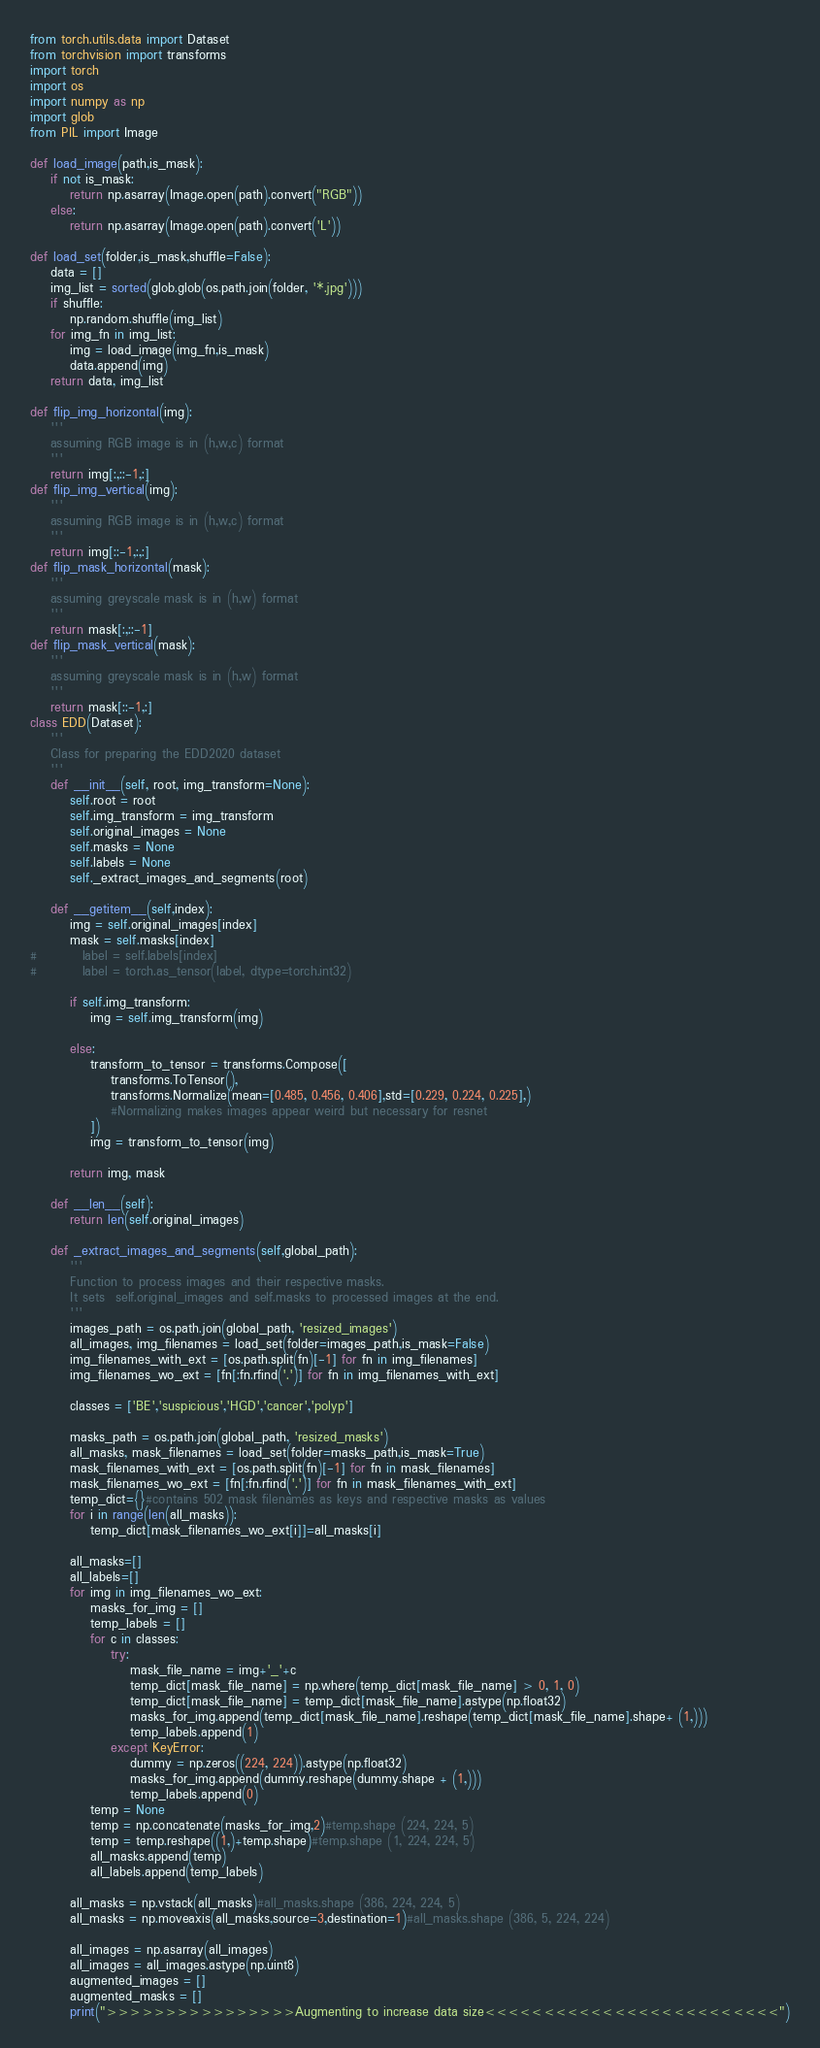Convert code to text. <code><loc_0><loc_0><loc_500><loc_500><_Python_>from torch.utils.data import Dataset
from torchvision import transforms
import torch
import os
import numpy as np
import glob
from PIL import Image

def load_image(path,is_mask):
    if not is_mask:
        return np.asarray(Image.open(path).convert("RGB"))
    else:
        return np.asarray(Image.open(path).convert('L'))

def load_set(folder,is_mask,shuffle=False):
    data = []
    img_list = sorted(glob.glob(os.path.join(folder, '*.jpg')))
    if shuffle:
        np.random.shuffle(img_list)
    for img_fn in img_list:
        img = load_image(img_fn,is_mask)
        data.append(img)
    return data, img_list

def flip_img_horizontal(img):
    '''
    assuming RGB image is in (h,w,c) format
    '''
    return img[:,::-1,:]
def flip_img_vertical(img):
    '''
    assuming RGB image is in (h,w,c) format
    '''
    return img[::-1,:,:]
def flip_mask_horizontal(mask):
    '''
    assuming greyscale mask is in (h,w) format
    '''
    return mask[:,::-1]
def flip_mask_vertical(mask):
    '''
    assuming greyscale mask is in (h,w) format
    '''
    return mask[::-1,:]
class EDD(Dataset):
    '''
    Class for preparing the EDD2020 dataset
    '''
    def __init__(self, root, img_transform=None):
        self.root = root
        self.img_transform = img_transform
        self.original_images = None
        self.masks = None
        self.labels = None
        self._extract_images_and_segments(root)

    def __getitem__(self,index):
        img = self.original_images[index]
        mask = self.masks[index]
#         label = self.labels[index]
#         label = torch.as_tensor(label, dtype=torch.int32)
    
        if self.img_transform:
            img = self.img_transform(img)
            
        else:
            transform_to_tensor = transforms.Compose([
                transforms.ToTensor(),
                transforms.Normalize(mean=[0.485, 0.456, 0.406],std=[0.229, 0.224, 0.225],)
                #Normalizing makes images appear weird but necessary for resnet
            ])
            img = transform_to_tensor(img)
        
        return img, mask

    def __len__(self):
        return len(self.original_images)
    
    def _extract_images_and_segments(self,global_path):
        '''
        Function to process images and their respective masks.
        It sets  self.original_images and self.masks to processed images at the end.
        '''
        images_path = os.path.join(global_path, 'resized_images')
        all_images, img_filenames = load_set(folder=images_path,is_mask=False)
        img_filenames_with_ext = [os.path.split(fn)[-1] for fn in img_filenames]
        img_filenames_wo_ext = [fn[:fn.rfind('.')] for fn in img_filenames_with_ext]

        classes = ['BE','suspicious','HGD','cancer','polyp']

        masks_path = os.path.join(global_path, 'resized_masks')
        all_masks, mask_filenames = load_set(folder=masks_path,is_mask=True)
        mask_filenames_with_ext = [os.path.split(fn)[-1] for fn in mask_filenames]
        mask_filenames_wo_ext = [fn[:fn.rfind('.')] for fn in mask_filenames_with_ext]
        temp_dict={}#contains 502 mask filenames as keys and respective masks as values
        for i in range(len(all_masks)):
            temp_dict[mask_filenames_wo_ext[i]]=all_masks[i]

        all_masks=[]
        all_labels=[]
        for img in img_filenames_wo_ext:
            masks_for_img = []
            temp_labels = []
            for c in classes:
                try:
                    mask_file_name = img+'_'+c
                    temp_dict[mask_file_name] = np.where(temp_dict[mask_file_name] > 0, 1, 0)
                    temp_dict[mask_file_name] = temp_dict[mask_file_name].astype(np.float32)
                    masks_for_img.append(temp_dict[mask_file_name].reshape(temp_dict[mask_file_name].shape+ (1,)))
                    temp_labels.append(1)
                except KeyError:
                    dummy = np.zeros((224, 224)).astype(np.float32)
                    masks_for_img.append(dummy.reshape(dummy.shape + (1,)))
                    temp_labels.append(0)
            temp = None
            temp = np.concatenate(masks_for_img,2)#temp.shape (224, 224, 5)
            temp = temp.reshape((1,)+temp.shape)#temp.shape (1, 224, 224, 5)
            all_masks.append(temp)
            all_labels.append(temp_labels)
            
        all_masks = np.vstack(all_masks)#all_masks.shape (386, 224, 224, 5)
        all_masks = np.moveaxis(all_masks,source=3,destination=1)#all_masks.shape (386, 5, 224, 224)
        
        all_images = np.asarray(all_images)
        all_images = all_images.astype(np.uint8)
        augmented_images = []
        augmented_masks = []
        print(">>>>>>>>>>>>>>>>Augmenting to increase data size<<<<<<<<<<<<<<<<<<<<<<<<<")</code> 